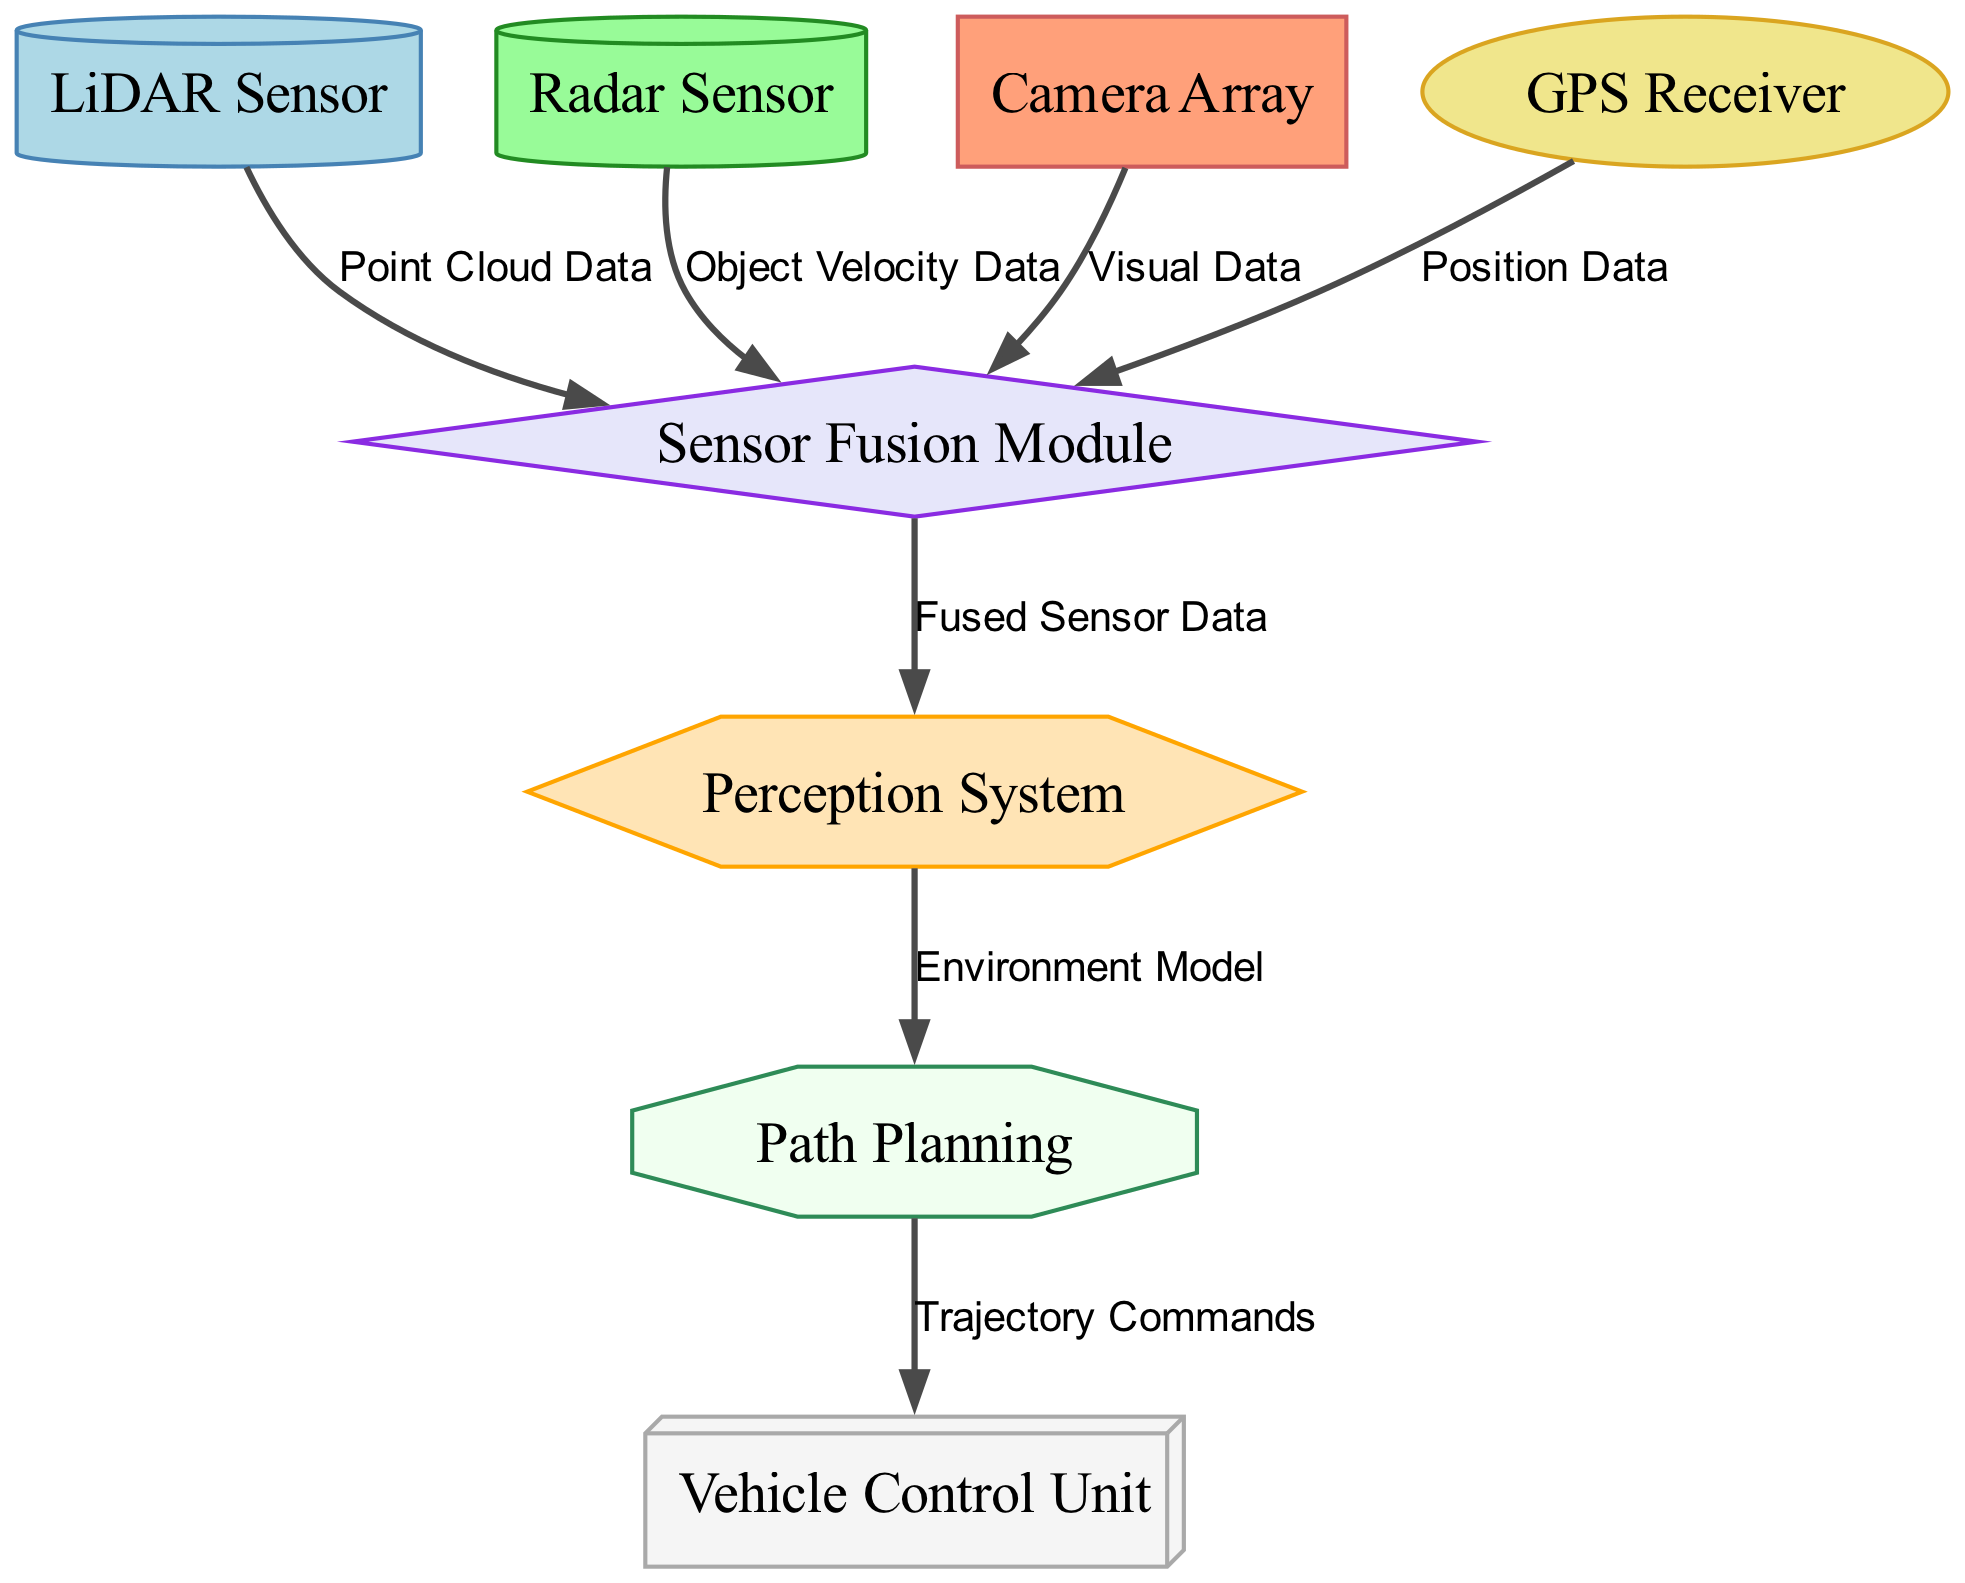what is the total number of nodes in the diagram? The diagram lists various components involved in autonomous vehicle sensor integration. By counting the entries in the "nodes" section of the data, we see there are eight components: LiDAR Sensor, Radar Sensor, Camera Array, GPS Receiver, Sensor Fusion Module, Perception System, Path Planning, and Vehicle Control Unit.
Answer: 8 which sensor provides Position Data? The edges connecting the nodes show the data flow paths. Looking at the edges, the GPS Receiver node connects to the Sensor Fusion Module with a label indicating it provides Position Data.
Answer: GPS Receiver what type of data does the Radar Sensor provide? Referring to the edges again, we see that the Radar Sensor connects to the Sensor Fusion Module with a label indicating it provides Object Velocity Data.
Answer: Object Velocity Data which module receives Fused Sensor Data? The edges indicate that the Sensor Fusion Module sends data to the Perception System, which is labeled as Fused Sensor Data. Thus, the Perception System receives this type of data.
Answer: Perception System how many edges connect the nodes? The data presented includes connections between multiple nodes, specifically in the "edges" section. There are seven edges listed, each indicating a relationship between two nodes.
Answer: 7 which component is at the end of the data flow path after Path Planning? After analyzing the flow of information, we see that the Path Planning module directs Trajectory Commands to the Vehicle Control Unit, making it the final component in this data chain.
Answer: Vehicle Control Unit what type of sensor is the Camera Array? Looking at the node descriptions, the Camera Array is labeled as a specific type of sensor that collects visual information for processing. Therefore, its type can be identified as a camera sensor.
Answer: Camera sensor what does the Perception System output? Following the data flow, the Perception System processes the Fused Sensor Data from the Sensor Fusion Module and outputs an Environment Model for further processing in the Path Planning stage.
Answer: Environment Model 